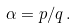<formula> <loc_0><loc_0><loc_500><loc_500>\alpha = p / q \, .</formula> 